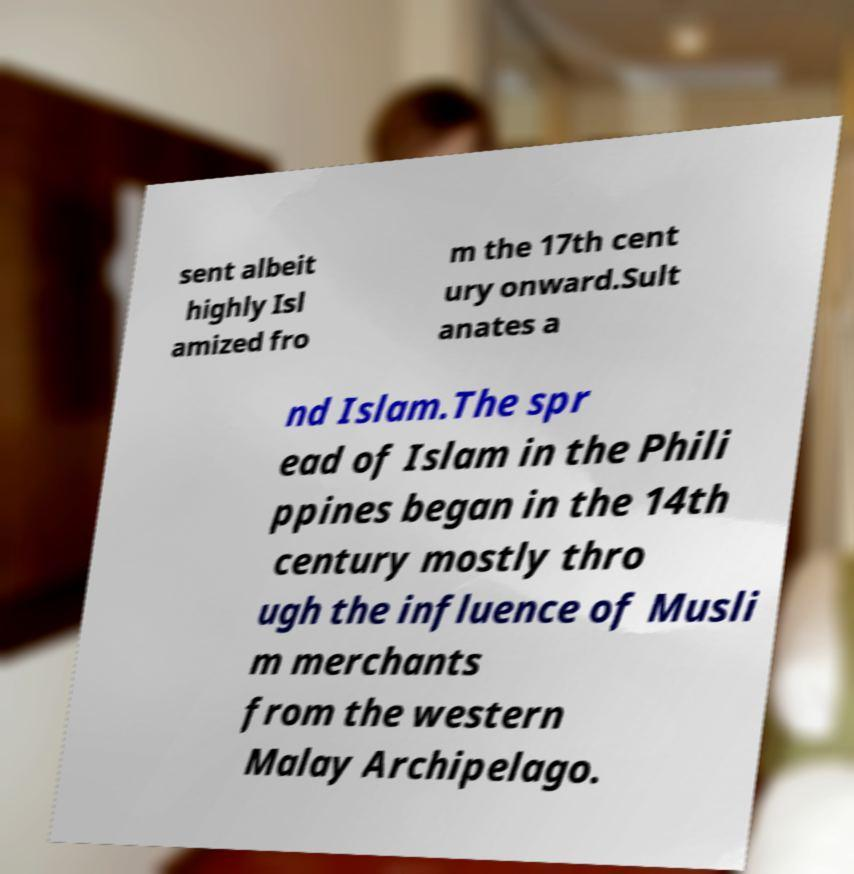Can you read and provide the text displayed in the image?This photo seems to have some interesting text. Can you extract and type it out for me? sent albeit highly Isl amized fro m the 17th cent ury onward.Sult anates a nd Islam.The spr ead of Islam in the Phili ppines began in the 14th century mostly thro ugh the influence of Musli m merchants from the western Malay Archipelago. 